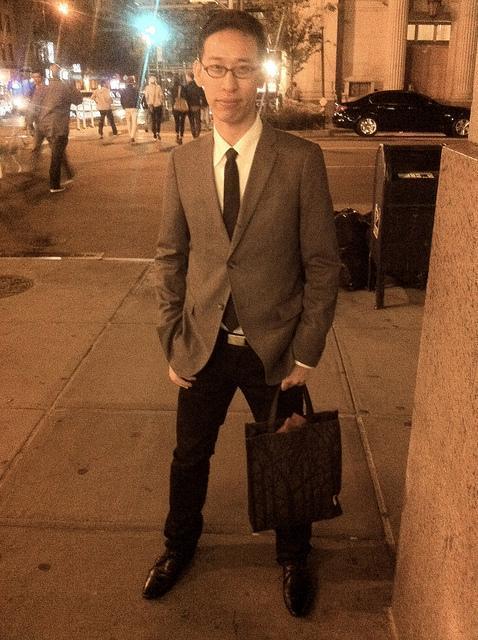How many handbags can you see?
Give a very brief answer. 1. How many people are in the photo?
Give a very brief answer. 2. How many cows are facing the camera?
Give a very brief answer. 0. 